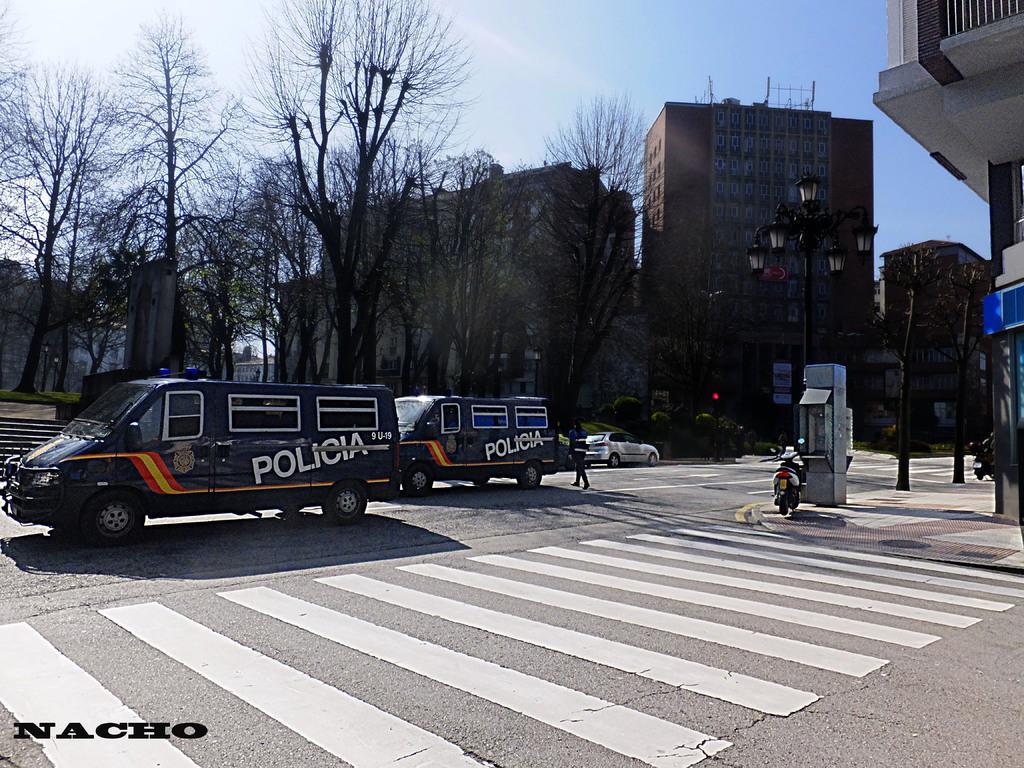In one or two sentences, can you explain what this image depicts? In this image we can see vehicles and a person on the road. In the background of the image, we can see trees, buildings and stairs. At the top of the image, there is the sky. On the right side of the image, we can see pavement, building, bike and one box like structure. 